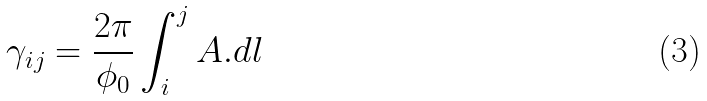Convert formula to latex. <formula><loc_0><loc_0><loc_500><loc_500>\gamma _ { i j } = { \frac { 2 \pi } { \phi _ { 0 } } } \int _ { i } ^ { j } { A } . d { l }</formula> 